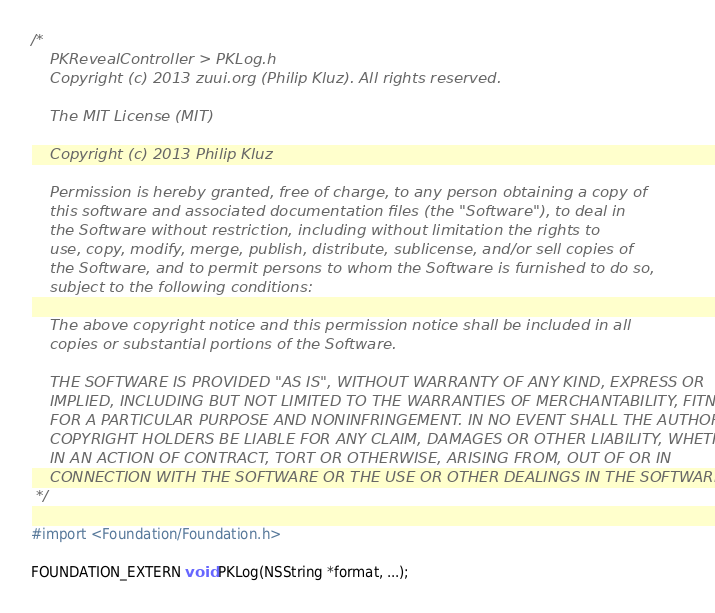<code> <loc_0><loc_0><loc_500><loc_500><_C_>/*
    PKRevealController > PKLog.h
    Copyright (c) 2013 zuui.org (Philip Kluz). All rights reserved.
 
    The MIT License (MIT)
 
    Copyright (c) 2013 Philip Kluz
 
    Permission is hereby granted, free of charge, to any person obtaining a copy of
    this software and associated documentation files (the "Software"), to deal in
    the Software without restriction, including without limitation the rights to
    use, copy, modify, merge, publish, distribute, sublicense, and/or sell copies of
    the Software, and to permit persons to whom the Software is furnished to do so,
    subject to the following conditions:
 
    The above copyright notice and this permission notice shall be included in all
    copies or substantial portions of the Software.
 
    THE SOFTWARE IS PROVIDED "AS IS", WITHOUT WARRANTY OF ANY KIND, EXPRESS OR
    IMPLIED, INCLUDING BUT NOT LIMITED TO THE WARRANTIES OF MERCHANTABILITY, FITNESS
    FOR A PARTICULAR PURPOSE AND NONINFRINGEMENT. IN NO EVENT SHALL THE AUTHORS OR
    COPYRIGHT HOLDERS BE LIABLE FOR ANY CLAIM, DAMAGES OR OTHER LIABILITY, WHETHER
    IN AN ACTION OF CONTRACT, TORT OR OTHERWISE, ARISING FROM, OUT OF OR IN
    CONNECTION WITH THE SOFTWARE OR THE USE OR OTHER DEALINGS IN THE SOFTWARE.
 */
 
#import <Foundation/Foundation.h>

FOUNDATION_EXTERN void PKLog(NSString *format, ...);
</code> 